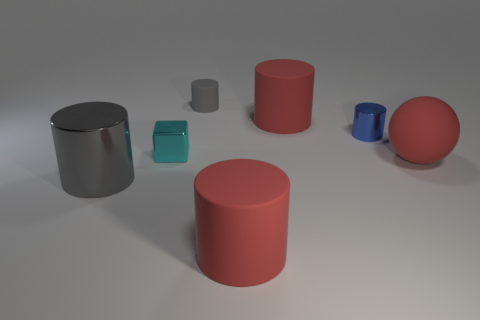Subtract all blue metallic cylinders. How many cylinders are left? 4 Add 3 large balls. How many objects exist? 10 Subtract all blue cylinders. How many cylinders are left? 4 Subtract 1 blocks. How many blocks are left? 0 Subtract all blocks. How many objects are left? 6 Add 5 gray objects. How many gray objects exist? 7 Subtract 0 brown balls. How many objects are left? 7 Subtract all blue cubes. Subtract all gray cylinders. How many cubes are left? 1 Subtract all red blocks. How many cyan cylinders are left? 0 Subtract all blue metal objects. Subtract all large gray metal objects. How many objects are left? 5 